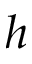Convert formula to latex. <formula><loc_0><loc_0><loc_500><loc_500>h</formula> 